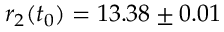<formula> <loc_0><loc_0><loc_500><loc_500>r _ { 2 } ( t _ { 0 } ) = 1 3 . 3 8 \pm 0 . 0 1</formula> 